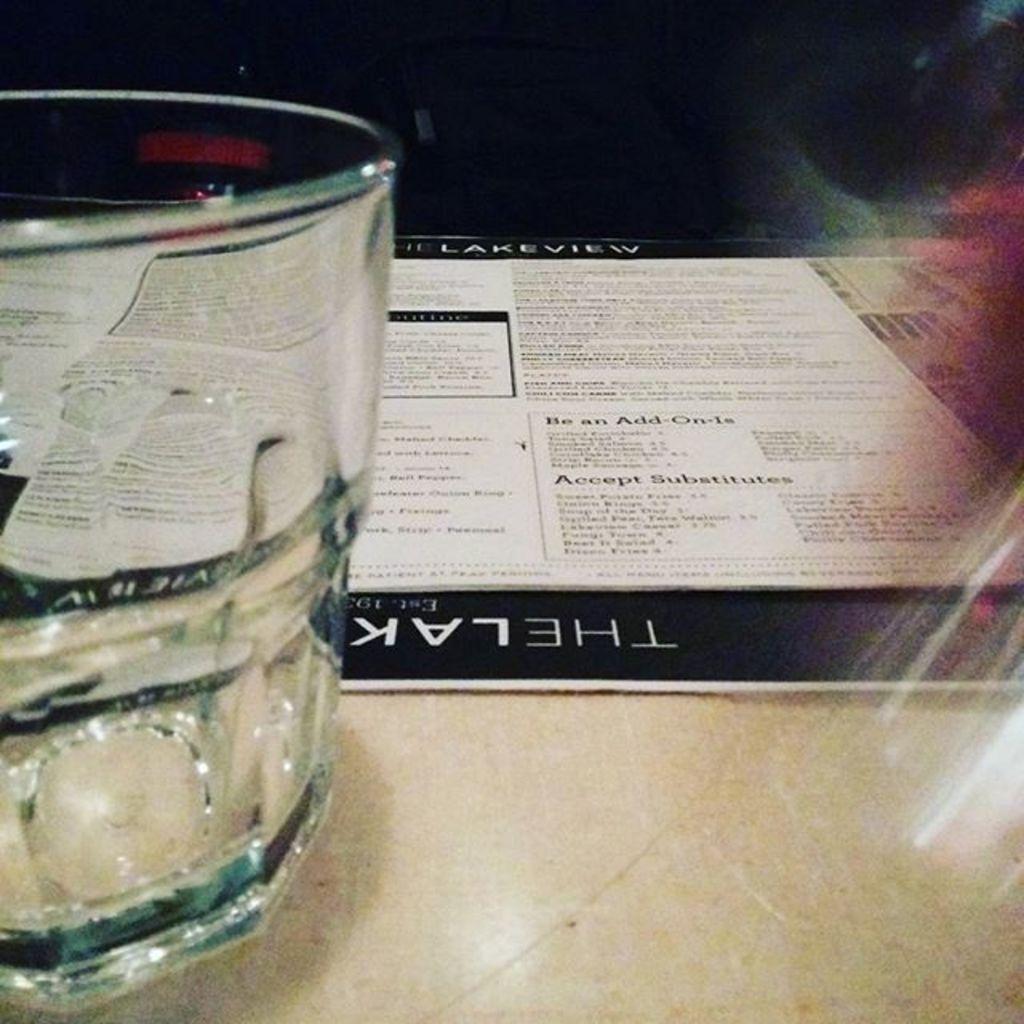What restaurant is this menu from?
Ensure brevity in your answer.  The lakeview. What is the last category on the menu?
Provide a short and direct response. Accept substitutes. 